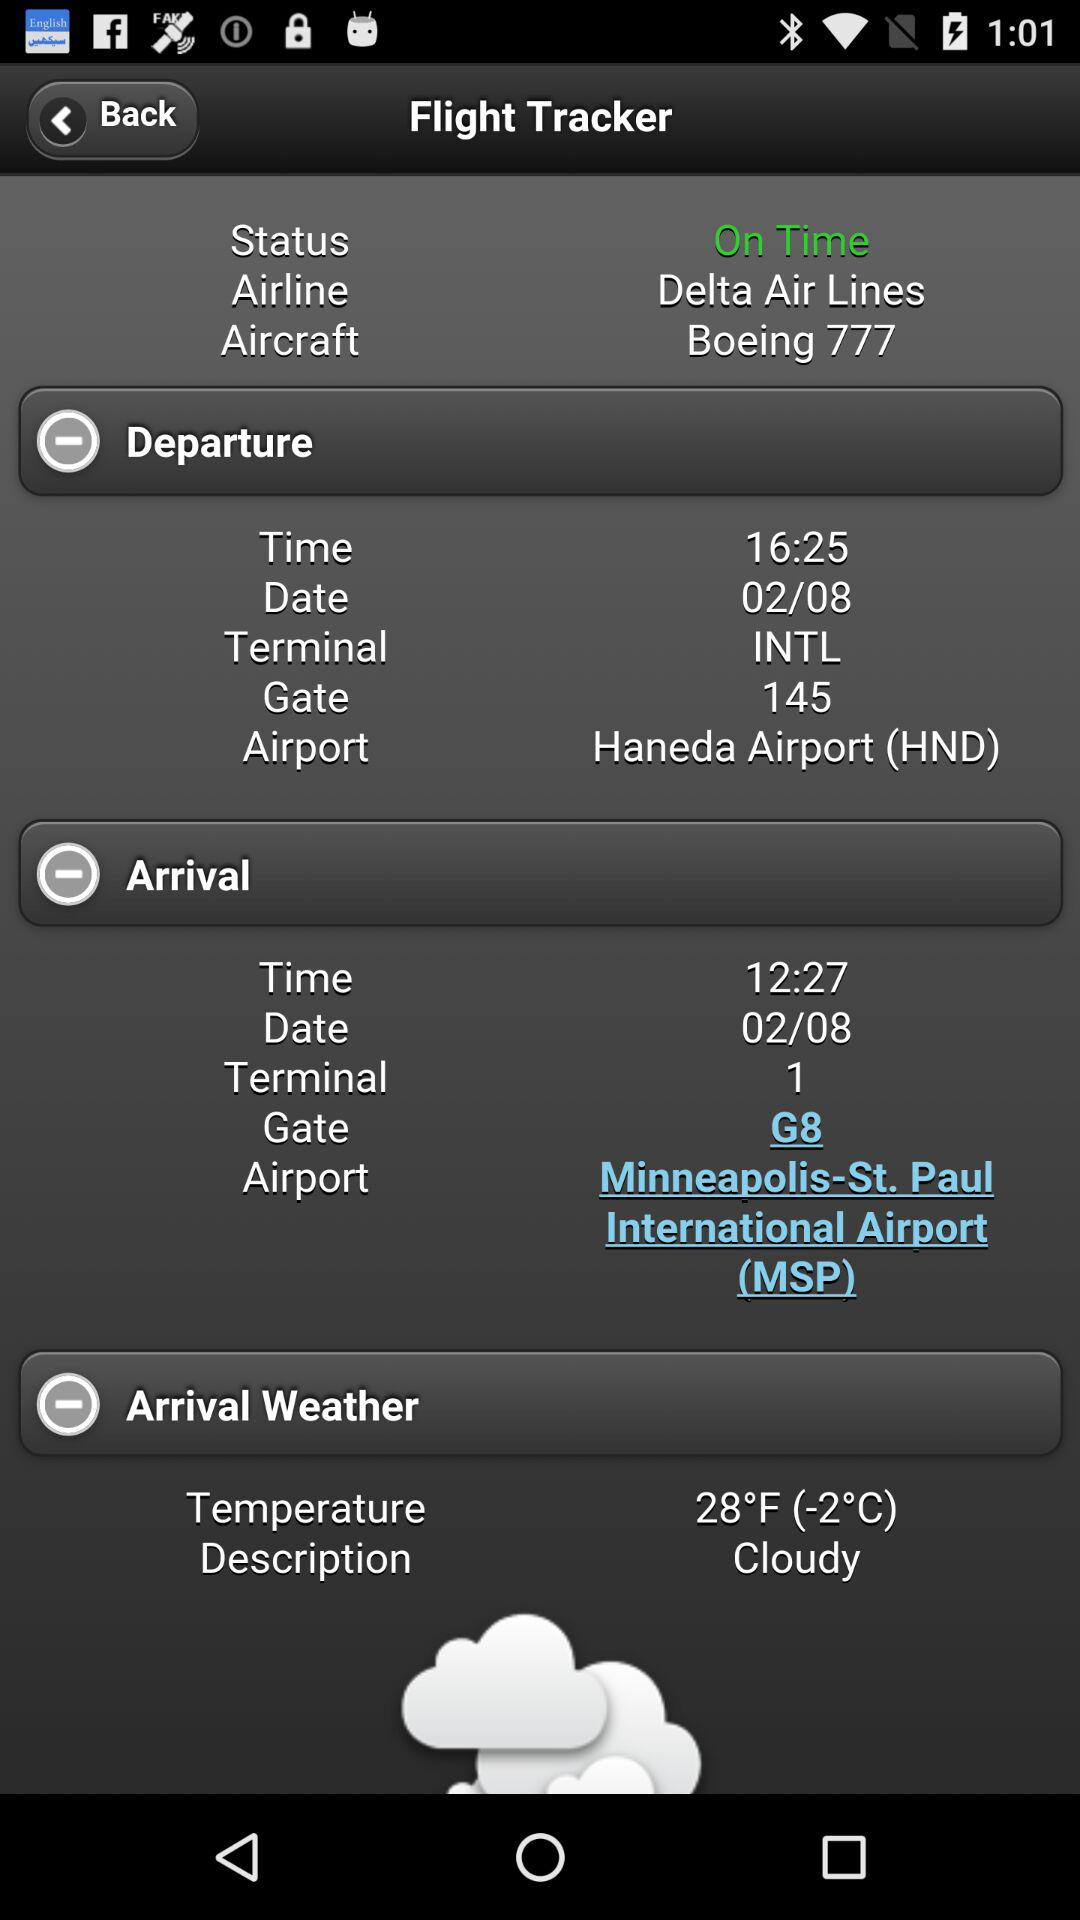What is the departure time of the flight? The departure time of the flight is 16:25. 